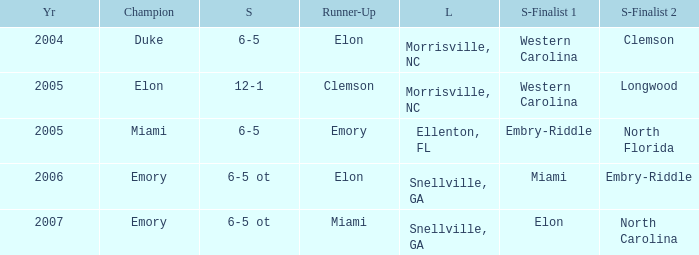Where was the final game played in 2007 Snellville, GA. 